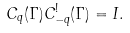Convert formula to latex. <formula><loc_0><loc_0><loc_500><loc_500>C _ { q } ( \Gamma ) C ^ { ! } _ { - q } ( \Gamma ) = I .</formula> 